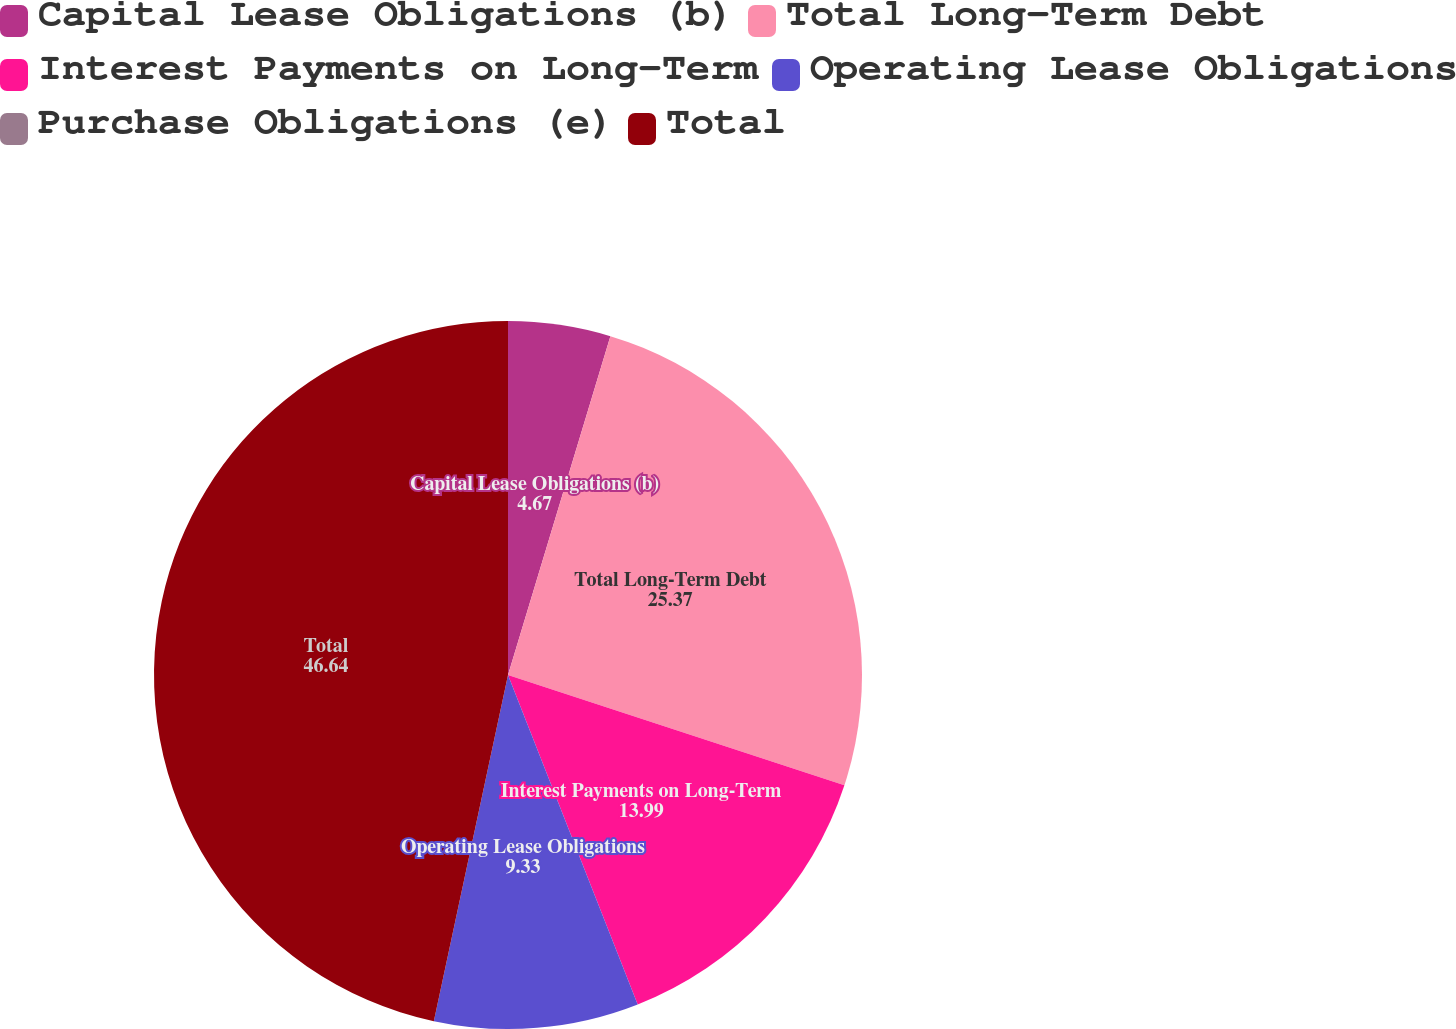<chart> <loc_0><loc_0><loc_500><loc_500><pie_chart><fcel>Capital Lease Obligations (b)<fcel>Total Long-Term Debt<fcel>Interest Payments on Long-Term<fcel>Operating Lease Obligations<fcel>Purchase Obligations (e)<fcel>Total<nl><fcel>4.67%<fcel>25.37%<fcel>13.99%<fcel>9.33%<fcel>0.0%<fcel>46.64%<nl></chart> 